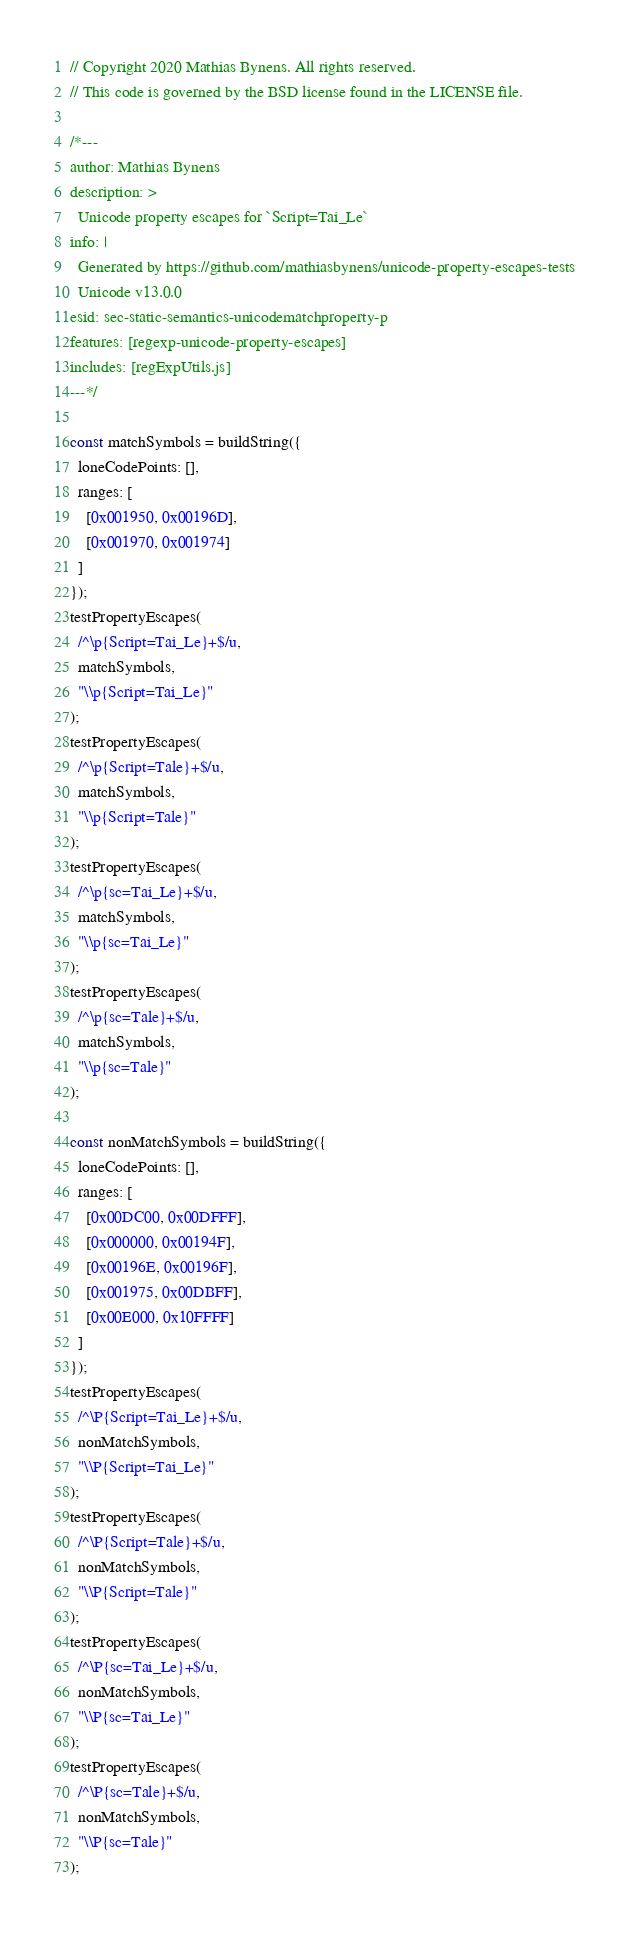<code> <loc_0><loc_0><loc_500><loc_500><_JavaScript_>// Copyright 2020 Mathias Bynens. All rights reserved.
// This code is governed by the BSD license found in the LICENSE file.

/*---
author: Mathias Bynens
description: >
  Unicode property escapes for `Script=Tai_Le`
info: |
  Generated by https://github.com/mathiasbynens/unicode-property-escapes-tests
  Unicode v13.0.0
esid: sec-static-semantics-unicodematchproperty-p
features: [regexp-unicode-property-escapes]
includes: [regExpUtils.js]
---*/

const matchSymbols = buildString({
  loneCodePoints: [],
  ranges: [
    [0x001950, 0x00196D],
    [0x001970, 0x001974]
  ]
});
testPropertyEscapes(
  /^\p{Script=Tai_Le}+$/u,
  matchSymbols,
  "\\p{Script=Tai_Le}"
);
testPropertyEscapes(
  /^\p{Script=Tale}+$/u,
  matchSymbols,
  "\\p{Script=Tale}"
);
testPropertyEscapes(
  /^\p{sc=Tai_Le}+$/u,
  matchSymbols,
  "\\p{sc=Tai_Le}"
);
testPropertyEscapes(
  /^\p{sc=Tale}+$/u,
  matchSymbols,
  "\\p{sc=Tale}"
);

const nonMatchSymbols = buildString({
  loneCodePoints: [],
  ranges: [
    [0x00DC00, 0x00DFFF],
    [0x000000, 0x00194F],
    [0x00196E, 0x00196F],
    [0x001975, 0x00DBFF],
    [0x00E000, 0x10FFFF]
  ]
});
testPropertyEscapes(
  /^\P{Script=Tai_Le}+$/u,
  nonMatchSymbols,
  "\\P{Script=Tai_Le}"
);
testPropertyEscapes(
  /^\P{Script=Tale}+$/u,
  nonMatchSymbols,
  "\\P{Script=Tale}"
);
testPropertyEscapes(
  /^\P{sc=Tai_Le}+$/u,
  nonMatchSymbols,
  "\\P{sc=Tai_Le}"
);
testPropertyEscapes(
  /^\P{sc=Tale}+$/u,
  nonMatchSymbols,
  "\\P{sc=Tale}"
);
</code> 